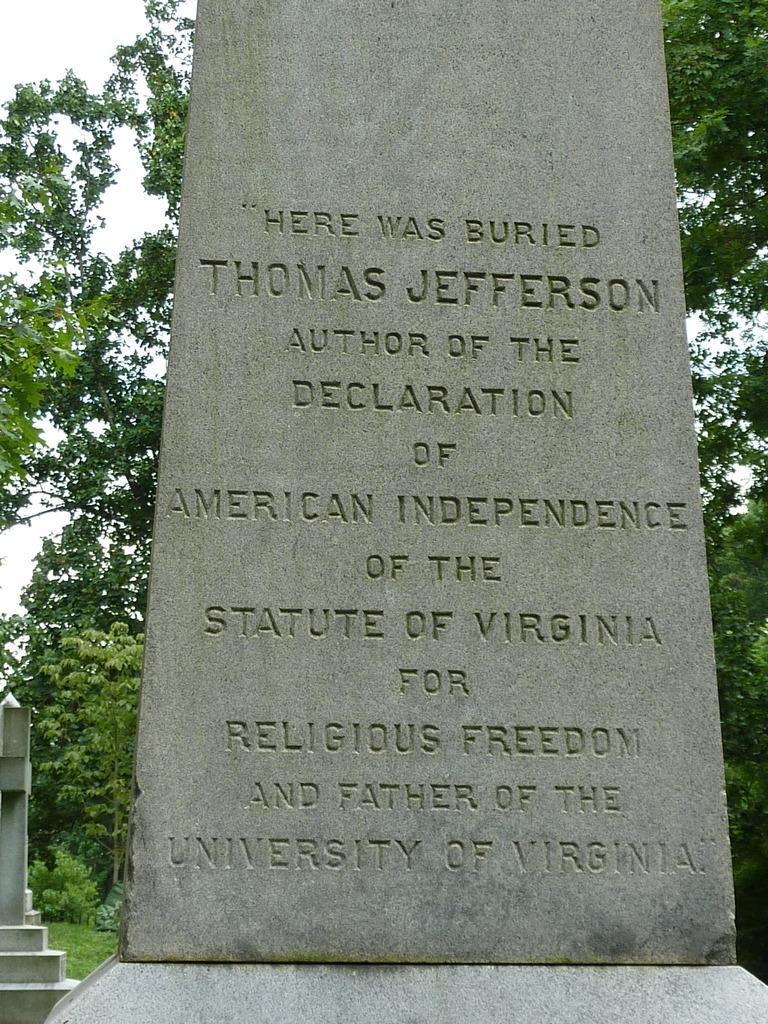How would you summarize this image in a sentence or two? Something written on this stone. Background there are trees, grass and sky. 